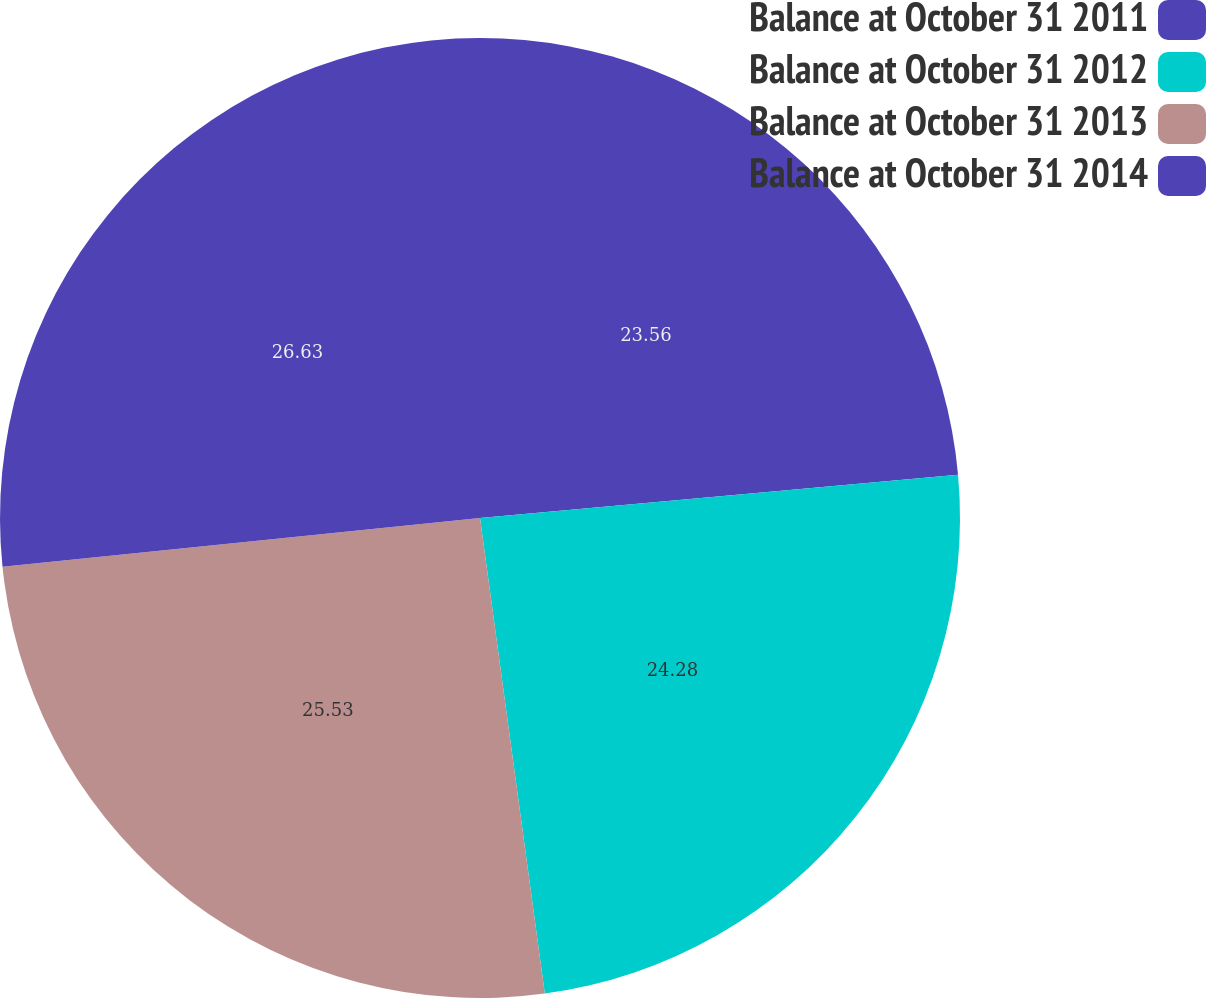<chart> <loc_0><loc_0><loc_500><loc_500><pie_chart><fcel>Balance at October 31 2011<fcel>Balance at October 31 2012<fcel>Balance at October 31 2013<fcel>Balance at October 31 2014<nl><fcel>23.56%<fcel>24.28%<fcel>25.53%<fcel>26.62%<nl></chart> 